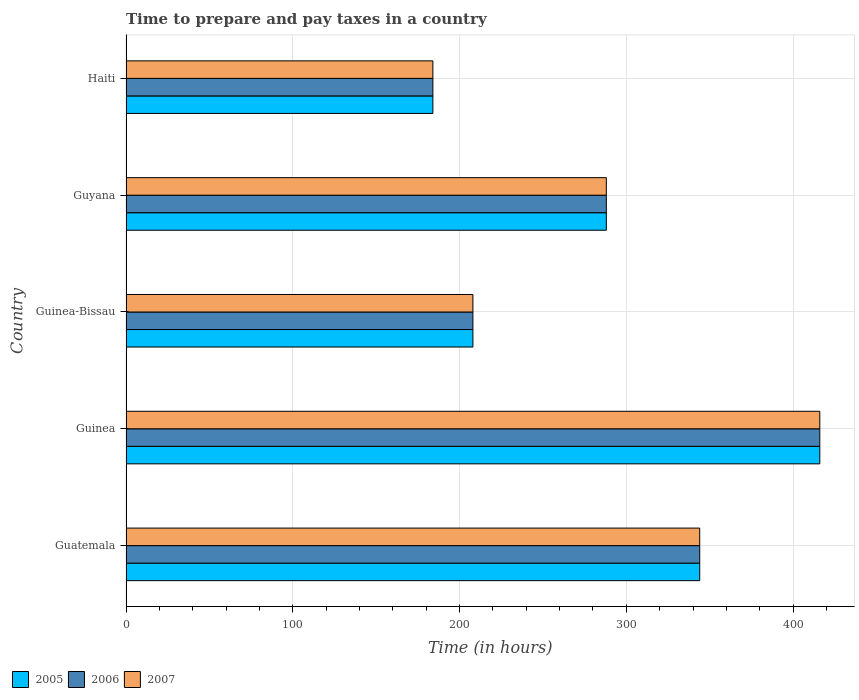How many different coloured bars are there?
Provide a short and direct response. 3. How many groups of bars are there?
Ensure brevity in your answer.  5. How many bars are there on the 5th tick from the top?
Ensure brevity in your answer.  3. What is the label of the 2nd group of bars from the top?
Give a very brief answer. Guyana. What is the number of hours required to prepare and pay taxes in 2007 in Guyana?
Offer a very short reply. 288. Across all countries, what is the maximum number of hours required to prepare and pay taxes in 2007?
Your response must be concise. 416. Across all countries, what is the minimum number of hours required to prepare and pay taxes in 2007?
Make the answer very short. 184. In which country was the number of hours required to prepare and pay taxes in 2005 maximum?
Offer a very short reply. Guinea. In which country was the number of hours required to prepare and pay taxes in 2007 minimum?
Your answer should be very brief. Haiti. What is the total number of hours required to prepare and pay taxes in 2006 in the graph?
Your answer should be compact. 1440. What is the average number of hours required to prepare and pay taxes in 2007 per country?
Ensure brevity in your answer.  288. In how many countries, is the number of hours required to prepare and pay taxes in 2007 greater than 360 hours?
Offer a very short reply. 1. What is the ratio of the number of hours required to prepare and pay taxes in 2007 in Guatemala to that in Haiti?
Give a very brief answer. 1.87. Is the difference between the number of hours required to prepare and pay taxes in 2005 in Guinea and Guyana greater than the difference between the number of hours required to prepare and pay taxes in 2007 in Guinea and Guyana?
Make the answer very short. No. What is the difference between the highest and the lowest number of hours required to prepare and pay taxes in 2007?
Offer a terse response. 232. Is the sum of the number of hours required to prepare and pay taxes in 2006 in Guatemala and Guinea-Bissau greater than the maximum number of hours required to prepare and pay taxes in 2005 across all countries?
Provide a short and direct response. Yes. What does the 3rd bar from the top in Guyana represents?
Your response must be concise. 2005. Are all the bars in the graph horizontal?
Provide a succinct answer. Yes. How many countries are there in the graph?
Provide a succinct answer. 5. What is the difference between two consecutive major ticks on the X-axis?
Provide a succinct answer. 100. Are the values on the major ticks of X-axis written in scientific E-notation?
Keep it short and to the point. No. Does the graph contain any zero values?
Provide a short and direct response. No. Does the graph contain grids?
Your answer should be compact. Yes. Where does the legend appear in the graph?
Your answer should be very brief. Bottom left. How many legend labels are there?
Your response must be concise. 3. How are the legend labels stacked?
Your answer should be compact. Horizontal. What is the title of the graph?
Offer a terse response. Time to prepare and pay taxes in a country. Does "1992" appear as one of the legend labels in the graph?
Your response must be concise. No. What is the label or title of the X-axis?
Offer a very short reply. Time (in hours). What is the Time (in hours) of 2005 in Guatemala?
Offer a very short reply. 344. What is the Time (in hours) in 2006 in Guatemala?
Keep it short and to the point. 344. What is the Time (in hours) in 2007 in Guatemala?
Your answer should be compact. 344. What is the Time (in hours) in 2005 in Guinea?
Your answer should be compact. 416. What is the Time (in hours) in 2006 in Guinea?
Your answer should be very brief. 416. What is the Time (in hours) of 2007 in Guinea?
Offer a terse response. 416. What is the Time (in hours) in 2005 in Guinea-Bissau?
Your response must be concise. 208. What is the Time (in hours) in 2006 in Guinea-Bissau?
Offer a terse response. 208. What is the Time (in hours) in 2007 in Guinea-Bissau?
Provide a short and direct response. 208. What is the Time (in hours) in 2005 in Guyana?
Your answer should be very brief. 288. What is the Time (in hours) in 2006 in Guyana?
Make the answer very short. 288. What is the Time (in hours) in 2007 in Guyana?
Offer a very short reply. 288. What is the Time (in hours) of 2005 in Haiti?
Ensure brevity in your answer.  184. What is the Time (in hours) in 2006 in Haiti?
Provide a succinct answer. 184. What is the Time (in hours) of 2007 in Haiti?
Make the answer very short. 184. Across all countries, what is the maximum Time (in hours) of 2005?
Keep it short and to the point. 416. Across all countries, what is the maximum Time (in hours) of 2006?
Provide a succinct answer. 416. Across all countries, what is the maximum Time (in hours) in 2007?
Your response must be concise. 416. Across all countries, what is the minimum Time (in hours) of 2005?
Provide a succinct answer. 184. Across all countries, what is the minimum Time (in hours) in 2006?
Ensure brevity in your answer.  184. Across all countries, what is the minimum Time (in hours) in 2007?
Give a very brief answer. 184. What is the total Time (in hours) of 2005 in the graph?
Ensure brevity in your answer.  1440. What is the total Time (in hours) of 2006 in the graph?
Make the answer very short. 1440. What is the total Time (in hours) in 2007 in the graph?
Make the answer very short. 1440. What is the difference between the Time (in hours) in 2005 in Guatemala and that in Guinea?
Make the answer very short. -72. What is the difference between the Time (in hours) of 2006 in Guatemala and that in Guinea?
Ensure brevity in your answer.  -72. What is the difference between the Time (in hours) in 2007 in Guatemala and that in Guinea?
Make the answer very short. -72. What is the difference between the Time (in hours) in 2005 in Guatemala and that in Guinea-Bissau?
Your response must be concise. 136. What is the difference between the Time (in hours) in 2006 in Guatemala and that in Guinea-Bissau?
Your answer should be very brief. 136. What is the difference between the Time (in hours) in 2007 in Guatemala and that in Guinea-Bissau?
Offer a very short reply. 136. What is the difference between the Time (in hours) in 2005 in Guatemala and that in Guyana?
Your answer should be very brief. 56. What is the difference between the Time (in hours) of 2005 in Guatemala and that in Haiti?
Your response must be concise. 160. What is the difference between the Time (in hours) in 2006 in Guatemala and that in Haiti?
Offer a terse response. 160. What is the difference between the Time (in hours) in 2007 in Guatemala and that in Haiti?
Make the answer very short. 160. What is the difference between the Time (in hours) in 2005 in Guinea and that in Guinea-Bissau?
Offer a terse response. 208. What is the difference between the Time (in hours) of 2006 in Guinea and that in Guinea-Bissau?
Keep it short and to the point. 208. What is the difference between the Time (in hours) of 2007 in Guinea and that in Guinea-Bissau?
Your response must be concise. 208. What is the difference between the Time (in hours) in 2005 in Guinea and that in Guyana?
Ensure brevity in your answer.  128. What is the difference between the Time (in hours) in 2006 in Guinea and that in Guyana?
Provide a succinct answer. 128. What is the difference between the Time (in hours) in 2007 in Guinea and that in Guyana?
Provide a succinct answer. 128. What is the difference between the Time (in hours) of 2005 in Guinea and that in Haiti?
Offer a terse response. 232. What is the difference between the Time (in hours) in 2006 in Guinea and that in Haiti?
Offer a terse response. 232. What is the difference between the Time (in hours) in 2007 in Guinea and that in Haiti?
Keep it short and to the point. 232. What is the difference between the Time (in hours) in 2005 in Guinea-Bissau and that in Guyana?
Offer a very short reply. -80. What is the difference between the Time (in hours) of 2006 in Guinea-Bissau and that in Guyana?
Provide a short and direct response. -80. What is the difference between the Time (in hours) in 2007 in Guinea-Bissau and that in Guyana?
Your answer should be very brief. -80. What is the difference between the Time (in hours) in 2005 in Guinea-Bissau and that in Haiti?
Make the answer very short. 24. What is the difference between the Time (in hours) in 2007 in Guinea-Bissau and that in Haiti?
Provide a succinct answer. 24. What is the difference between the Time (in hours) of 2005 in Guyana and that in Haiti?
Give a very brief answer. 104. What is the difference between the Time (in hours) in 2006 in Guyana and that in Haiti?
Your response must be concise. 104. What is the difference between the Time (in hours) of 2007 in Guyana and that in Haiti?
Ensure brevity in your answer.  104. What is the difference between the Time (in hours) in 2005 in Guatemala and the Time (in hours) in 2006 in Guinea?
Your answer should be compact. -72. What is the difference between the Time (in hours) of 2005 in Guatemala and the Time (in hours) of 2007 in Guinea?
Your answer should be very brief. -72. What is the difference between the Time (in hours) of 2006 in Guatemala and the Time (in hours) of 2007 in Guinea?
Provide a short and direct response. -72. What is the difference between the Time (in hours) of 2005 in Guatemala and the Time (in hours) of 2006 in Guinea-Bissau?
Your answer should be very brief. 136. What is the difference between the Time (in hours) of 2005 in Guatemala and the Time (in hours) of 2007 in Guinea-Bissau?
Ensure brevity in your answer.  136. What is the difference between the Time (in hours) in 2006 in Guatemala and the Time (in hours) in 2007 in Guinea-Bissau?
Ensure brevity in your answer.  136. What is the difference between the Time (in hours) of 2005 in Guatemala and the Time (in hours) of 2006 in Guyana?
Offer a terse response. 56. What is the difference between the Time (in hours) of 2006 in Guatemala and the Time (in hours) of 2007 in Guyana?
Your answer should be very brief. 56. What is the difference between the Time (in hours) of 2005 in Guatemala and the Time (in hours) of 2006 in Haiti?
Your response must be concise. 160. What is the difference between the Time (in hours) in 2005 in Guatemala and the Time (in hours) in 2007 in Haiti?
Your answer should be compact. 160. What is the difference between the Time (in hours) of 2006 in Guatemala and the Time (in hours) of 2007 in Haiti?
Keep it short and to the point. 160. What is the difference between the Time (in hours) of 2005 in Guinea and the Time (in hours) of 2006 in Guinea-Bissau?
Offer a terse response. 208. What is the difference between the Time (in hours) of 2005 in Guinea and the Time (in hours) of 2007 in Guinea-Bissau?
Provide a succinct answer. 208. What is the difference between the Time (in hours) of 2006 in Guinea and the Time (in hours) of 2007 in Guinea-Bissau?
Your answer should be very brief. 208. What is the difference between the Time (in hours) in 2005 in Guinea and the Time (in hours) in 2006 in Guyana?
Offer a very short reply. 128. What is the difference between the Time (in hours) of 2005 in Guinea and the Time (in hours) of 2007 in Guyana?
Provide a succinct answer. 128. What is the difference between the Time (in hours) of 2006 in Guinea and the Time (in hours) of 2007 in Guyana?
Provide a short and direct response. 128. What is the difference between the Time (in hours) of 2005 in Guinea and the Time (in hours) of 2006 in Haiti?
Offer a terse response. 232. What is the difference between the Time (in hours) of 2005 in Guinea and the Time (in hours) of 2007 in Haiti?
Provide a short and direct response. 232. What is the difference between the Time (in hours) in 2006 in Guinea and the Time (in hours) in 2007 in Haiti?
Your response must be concise. 232. What is the difference between the Time (in hours) of 2005 in Guinea-Bissau and the Time (in hours) of 2006 in Guyana?
Your response must be concise. -80. What is the difference between the Time (in hours) in 2005 in Guinea-Bissau and the Time (in hours) in 2007 in Guyana?
Provide a succinct answer. -80. What is the difference between the Time (in hours) of 2006 in Guinea-Bissau and the Time (in hours) of 2007 in Guyana?
Offer a terse response. -80. What is the difference between the Time (in hours) in 2005 in Guinea-Bissau and the Time (in hours) in 2006 in Haiti?
Keep it short and to the point. 24. What is the difference between the Time (in hours) in 2006 in Guinea-Bissau and the Time (in hours) in 2007 in Haiti?
Offer a very short reply. 24. What is the difference between the Time (in hours) of 2005 in Guyana and the Time (in hours) of 2006 in Haiti?
Keep it short and to the point. 104. What is the difference between the Time (in hours) in 2005 in Guyana and the Time (in hours) in 2007 in Haiti?
Provide a succinct answer. 104. What is the difference between the Time (in hours) in 2006 in Guyana and the Time (in hours) in 2007 in Haiti?
Offer a terse response. 104. What is the average Time (in hours) in 2005 per country?
Your response must be concise. 288. What is the average Time (in hours) in 2006 per country?
Give a very brief answer. 288. What is the average Time (in hours) of 2007 per country?
Ensure brevity in your answer.  288. What is the difference between the Time (in hours) in 2005 and Time (in hours) in 2006 in Guatemala?
Ensure brevity in your answer.  0. What is the difference between the Time (in hours) in 2005 and Time (in hours) in 2007 in Guatemala?
Keep it short and to the point. 0. What is the difference between the Time (in hours) in 2005 and Time (in hours) in 2006 in Guinea?
Make the answer very short. 0. What is the difference between the Time (in hours) in 2005 and Time (in hours) in 2007 in Guinea?
Give a very brief answer. 0. What is the difference between the Time (in hours) in 2006 and Time (in hours) in 2007 in Guinea?
Your answer should be compact. 0. What is the difference between the Time (in hours) in 2005 and Time (in hours) in 2006 in Guinea-Bissau?
Give a very brief answer. 0. What is the difference between the Time (in hours) of 2006 and Time (in hours) of 2007 in Guinea-Bissau?
Your answer should be very brief. 0. What is the difference between the Time (in hours) of 2005 and Time (in hours) of 2006 in Guyana?
Your response must be concise. 0. What is the difference between the Time (in hours) of 2005 and Time (in hours) of 2007 in Guyana?
Your answer should be compact. 0. What is the difference between the Time (in hours) of 2006 and Time (in hours) of 2007 in Guyana?
Provide a short and direct response. 0. What is the ratio of the Time (in hours) of 2005 in Guatemala to that in Guinea?
Ensure brevity in your answer.  0.83. What is the ratio of the Time (in hours) in 2006 in Guatemala to that in Guinea?
Make the answer very short. 0.83. What is the ratio of the Time (in hours) in 2007 in Guatemala to that in Guinea?
Offer a terse response. 0.83. What is the ratio of the Time (in hours) of 2005 in Guatemala to that in Guinea-Bissau?
Offer a terse response. 1.65. What is the ratio of the Time (in hours) of 2006 in Guatemala to that in Guinea-Bissau?
Keep it short and to the point. 1.65. What is the ratio of the Time (in hours) of 2007 in Guatemala to that in Guinea-Bissau?
Provide a succinct answer. 1.65. What is the ratio of the Time (in hours) of 2005 in Guatemala to that in Guyana?
Give a very brief answer. 1.19. What is the ratio of the Time (in hours) in 2006 in Guatemala to that in Guyana?
Your answer should be very brief. 1.19. What is the ratio of the Time (in hours) in 2007 in Guatemala to that in Guyana?
Provide a short and direct response. 1.19. What is the ratio of the Time (in hours) of 2005 in Guatemala to that in Haiti?
Your answer should be compact. 1.87. What is the ratio of the Time (in hours) of 2006 in Guatemala to that in Haiti?
Give a very brief answer. 1.87. What is the ratio of the Time (in hours) in 2007 in Guatemala to that in Haiti?
Keep it short and to the point. 1.87. What is the ratio of the Time (in hours) of 2006 in Guinea to that in Guinea-Bissau?
Provide a succinct answer. 2. What is the ratio of the Time (in hours) of 2005 in Guinea to that in Guyana?
Your response must be concise. 1.44. What is the ratio of the Time (in hours) of 2006 in Guinea to that in Guyana?
Make the answer very short. 1.44. What is the ratio of the Time (in hours) in 2007 in Guinea to that in Guyana?
Give a very brief answer. 1.44. What is the ratio of the Time (in hours) in 2005 in Guinea to that in Haiti?
Offer a terse response. 2.26. What is the ratio of the Time (in hours) in 2006 in Guinea to that in Haiti?
Provide a succinct answer. 2.26. What is the ratio of the Time (in hours) in 2007 in Guinea to that in Haiti?
Give a very brief answer. 2.26. What is the ratio of the Time (in hours) of 2005 in Guinea-Bissau to that in Guyana?
Ensure brevity in your answer.  0.72. What is the ratio of the Time (in hours) in 2006 in Guinea-Bissau to that in Guyana?
Make the answer very short. 0.72. What is the ratio of the Time (in hours) of 2007 in Guinea-Bissau to that in Guyana?
Make the answer very short. 0.72. What is the ratio of the Time (in hours) in 2005 in Guinea-Bissau to that in Haiti?
Your answer should be very brief. 1.13. What is the ratio of the Time (in hours) in 2006 in Guinea-Bissau to that in Haiti?
Provide a short and direct response. 1.13. What is the ratio of the Time (in hours) of 2007 in Guinea-Bissau to that in Haiti?
Your answer should be compact. 1.13. What is the ratio of the Time (in hours) of 2005 in Guyana to that in Haiti?
Ensure brevity in your answer.  1.57. What is the ratio of the Time (in hours) in 2006 in Guyana to that in Haiti?
Your response must be concise. 1.57. What is the ratio of the Time (in hours) in 2007 in Guyana to that in Haiti?
Your answer should be very brief. 1.57. What is the difference between the highest and the second highest Time (in hours) of 2005?
Ensure brevity in your answer.  72. What is the difference between the highest and the lowest Time (in hours) in 2005?
Provide a succinct answer. 232. What is the difference between the highest and the lowest Time (in hours) in 2006?
Your answer should be compact. 232. What is the difference between the highest and the lowest Time (in hours) in 2007?
Give a very brief answer. 232. 